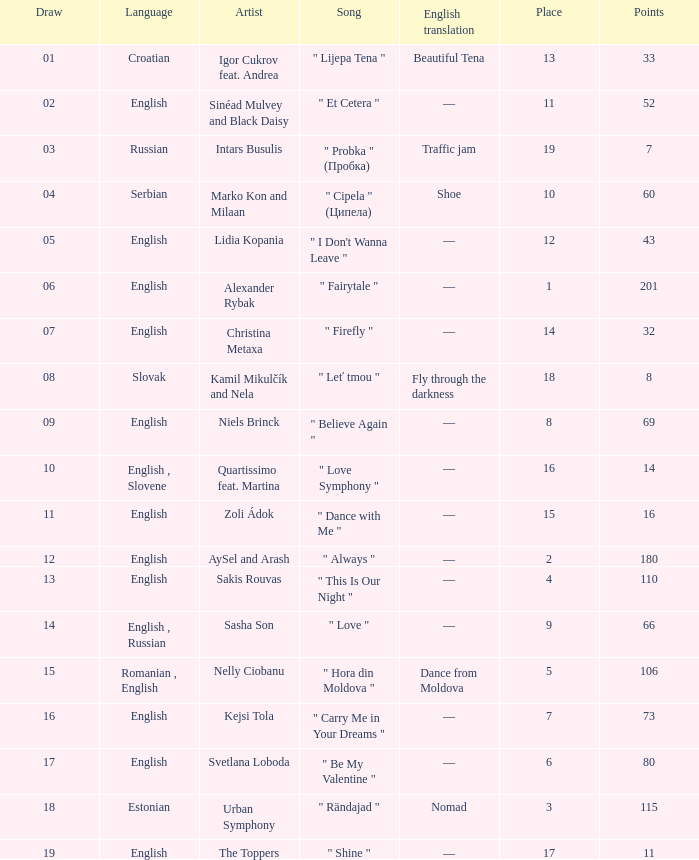What is the median points when the artist is kamil mikulčík and nela, and the location is bigger than 18? None. 